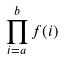Convert formula to latex. <formula><loc_0><loc_0><loc_500><loc_500>\prod _ { i = a } ^ { b } f ( i )</formula> 